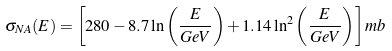Convert formula to latex. <formula><loc_0><loc_0><loc_500><loc_500>\sigma _ { N A } ( E ) = \left [ 2 8 0 - 8 . 7 \ln \left ( \frac { E } { G e V } \right ) + 1 . 1 4 \ln ^ { 2 } \left ( \frac { E } { G e V } \right ) \right ] m b</formula> 